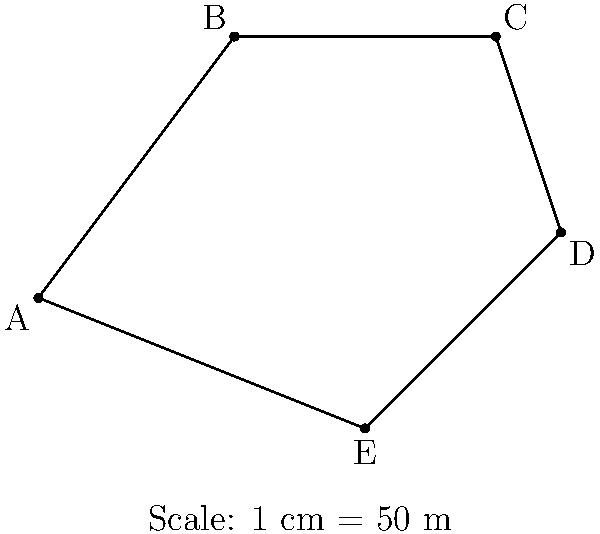You're designing a new park with an irregular pentagonal shape. The scaled map shows the park's boundary, where 1 cm on the map represents 50 meters in real life. Calculate the actual perimeter of the park in kilometers. To solve this problem, we'll follow these steps:

1) Measure the lengths of each side on the map:
   AB ≈ 5 cm
   BC ≈ 4 cm
   CD ≈ 3.16 cm
   DE ≈ 3.61 cm
   EA ≈ 5.10 cm

2) Sum up the lengths:
   Total length on map = 5 + 4 + 3.16 + 3.61 + 5.10 = 20.87 cm

3) Convert the map distance to real distance:
   If 1 cm = 50 m, then 20.87 cm = 20.87 × 50 = 1043.5 m

4) Convert meters to kilometers:
   1043.5 m = 1.0435 km

Therefore, the actual perimeter of the park is approximately 1.0435 km.
Answer: $1.0435$ km 